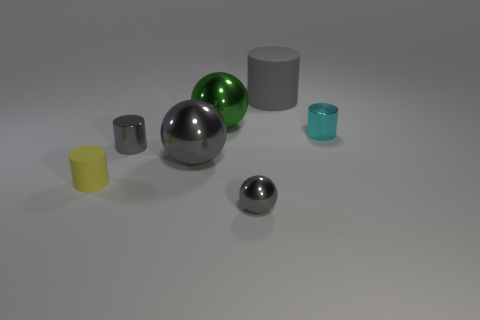Subtract 1 cylinders. How many cylinders are left? 3 Add 2 tiny objects. How many objects exist? 9 Subtract all spheres. How many objects are left? 4 Add 4 tiny cyan metal cylinders. How many tiny cyan metal cylinders are left? 5 Add 3 shiny things. How many shiny things exist? 8 Subtract 1 green spheres. How many objects are left? 6 Subtract all small brown metallic cylinders. Subtract all tiny gray things. How many objects are left? 5 